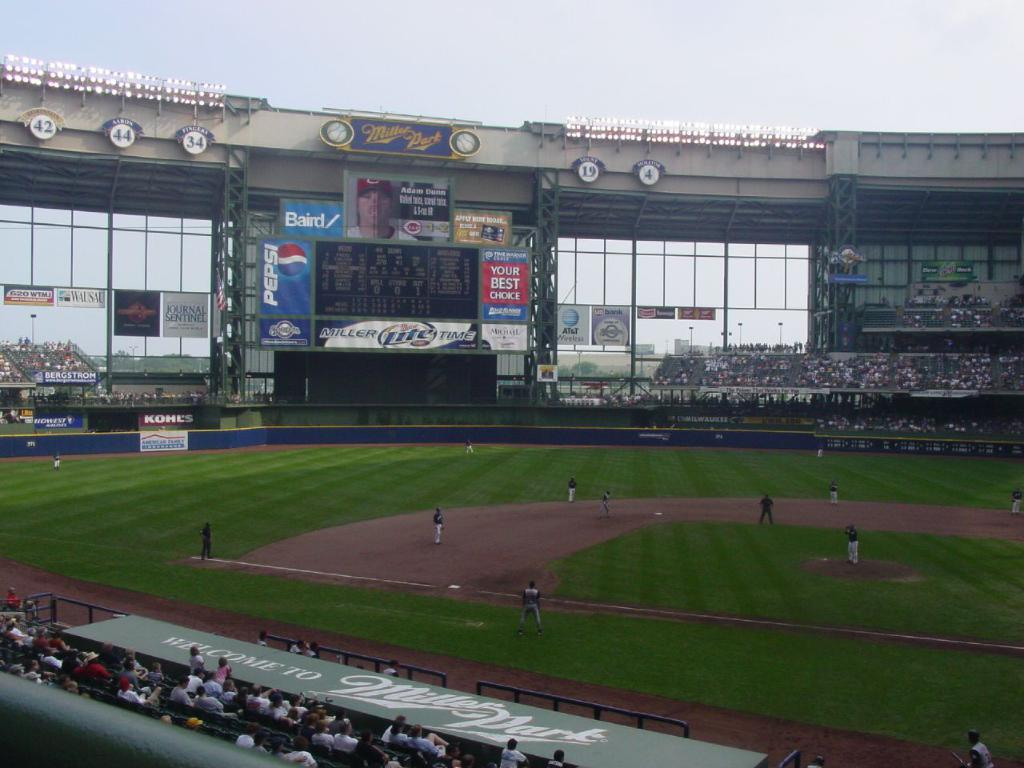<image>
Describe the image concisely. A baseball game is taking place in a stadium called Miller Park. 